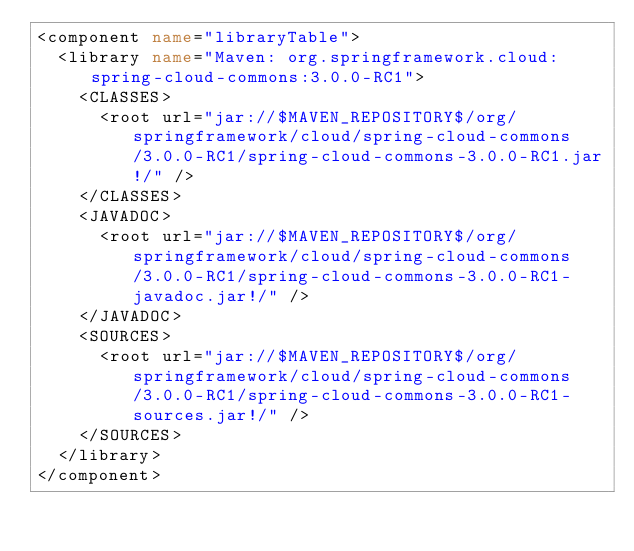<code> <loc_0><loc_0><loc_500><loc_500><_XML_><component name="libraryTable">
  <library name="Maven: org.springframework.cloud:spring-cloud-commons:3.0.0-RC1">
    <CLASSES>
      <root url="jar://$MAVEN_REPOSITORY$/org/springframework/cloud/spring-cloud-commons/3.0.0-RC1/spring-cloud-commons-3.0.0-RC1.jar!/" />
    </CLASSES>
    <JAVADOC>
      <root url="jar://$MAVEN_REPOSITORY$/org/springframework/cloud/spring-cloud-commons/3.0.0-RC1/spring-cloud-commons-3.0.0-RC1-javadoc.jar!/" />
    </JAVADOC>
    <SOURCES>
      <root url="jar://$MAVEN_REPOSITORY$/org/springframework/cloud/spring-cloud-commons/3.0.0-RC1/spring-cloud-commons-3.0.0-RC1-sources.jar!/" />
    </SOURCES>
  </library>
</component></code> 